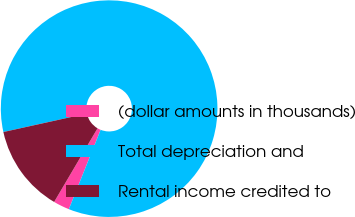<chart> <loc_0><loc_0><loc_500><loc_500><pie_chart><fcel>(dollar amounts in thousands)<fcel>Total depreciation and<fcel>Rental income credited to<nl><fcel>2.41%<fcel>84.53%<fcel>13.06%<nl></chart> 